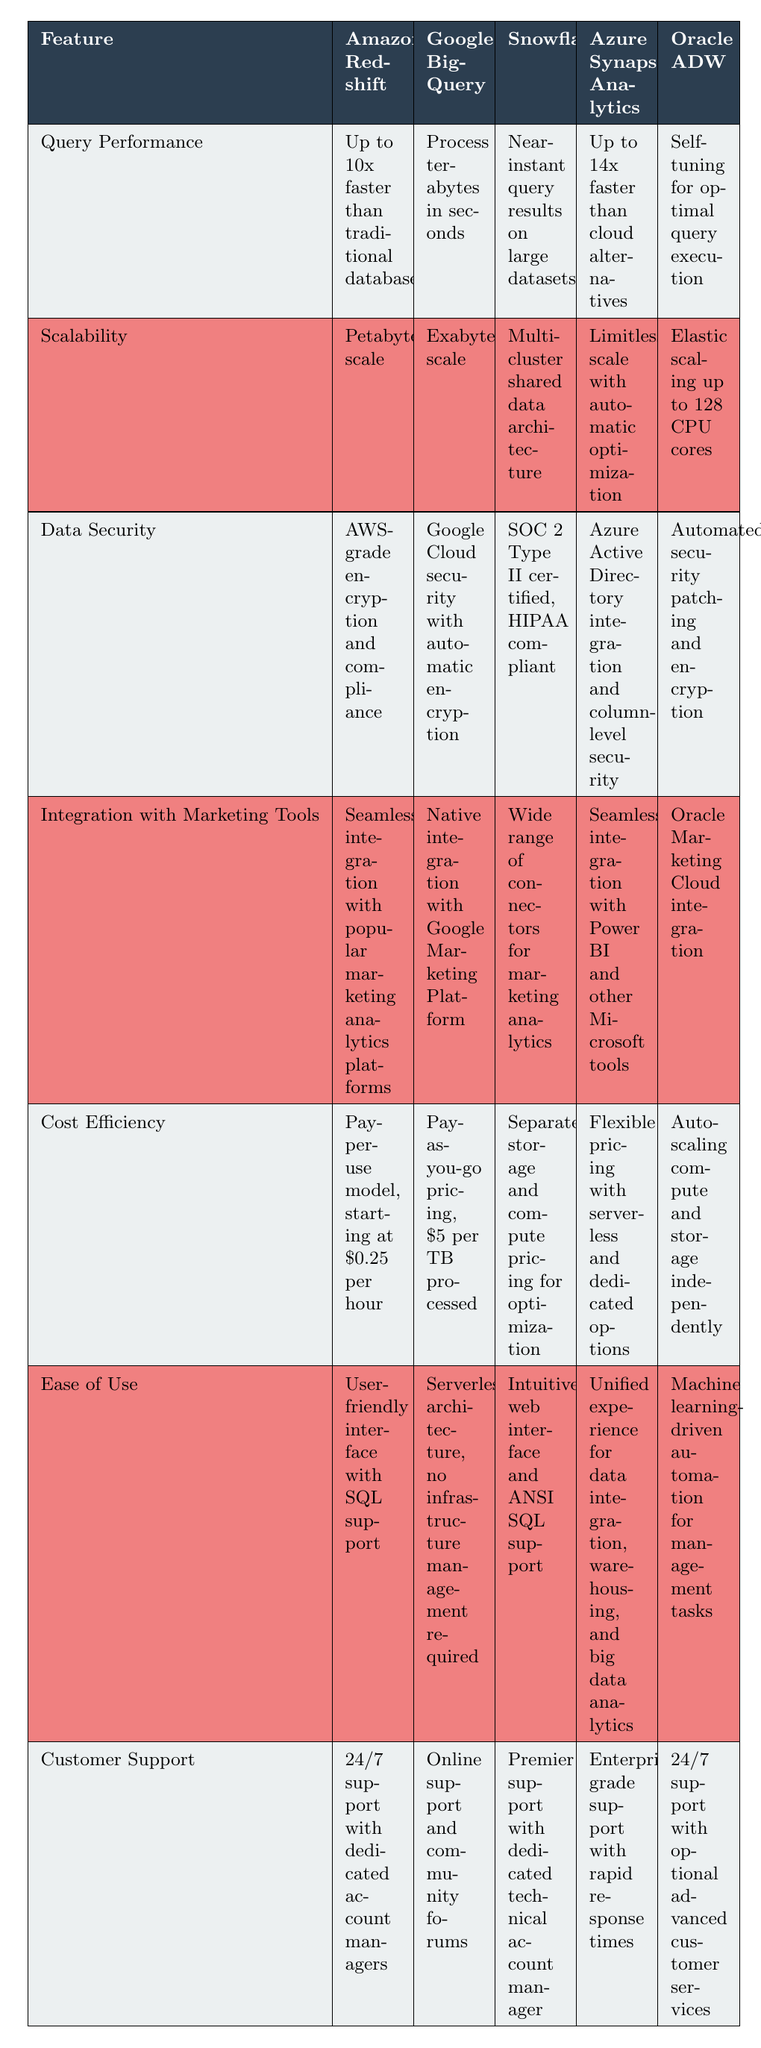What is the query performance of Microsoft Azure Synapse Analytics? Referring to the row for Microsoft Azure Synapse Analytics, it shows "Up to 14x faster than cloud alternatives" under the query performance feature.
Answer: Up to 14x faster than cloud alternatives Which solution offers petabyte-scale scalability? Looking at the scalability row, only Amazon Redshift is listed with "Petabyte-scale" scalability.
Answer: Amazon Redshift Is Google BigQuery compliant with security standards? From the data security row for Google BigQuery, it states "Google Cloud security with automatic encryption," indicating that it has strong security protocols.
Answer: Yes What are the customer support options for Snowflake? The table indicates that Snowflake offers "Premier support with dedicated technical account manager" under the customer support row.
Answer: Premier support with dedicated technical account manager How does the data security of Oracle Autonomous Data Warehouse compare to that of Snowflake? By checking the data security row, Oracle Autonomous Data Warehouse states "Automated security patching and encryption," while Snowflake states "SOC 2 Type II certified, HIPAA compliant." Both have strong security measures, but the certifications differ.
Answer: Different; Oracle ADW has automated security patching; Snowflake is SOC 2 and HIPAA compliant What is the cost efficiency of using Google BigQuery for processing 10 TB of data? The cost efficiency row shows an option of "Pay-as-you-go pricing, $5 per TB processed." For 10 TB, the total cost would be calculated as 10 * 5 = 50.
Answer: $50 Which cloud solution has the broadest scalability option? The scalability row shows that Google BigQuery features "Exabyte-scale," which is the highest compared to others.
Answer: Google BigQuery How many types of customer support are available for Amazon Redshift? Amazon Redshift offers "24/7 support with dedicated account managers," indicating there's one type of dedicated support available.
Answer: 1 type 